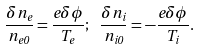<formula> <loc_0><loc_0><loc_500><loc_500>\frac { \delta n _ { e } } { n _ { e 0 } } = \frac { e \delta \phi } { T _ { e } } ; \, \ \frac { \delta n _ { i } } { n _ { i 0 } } = - \frac { e \delta \phi } { T _ { i } } .</formula> 